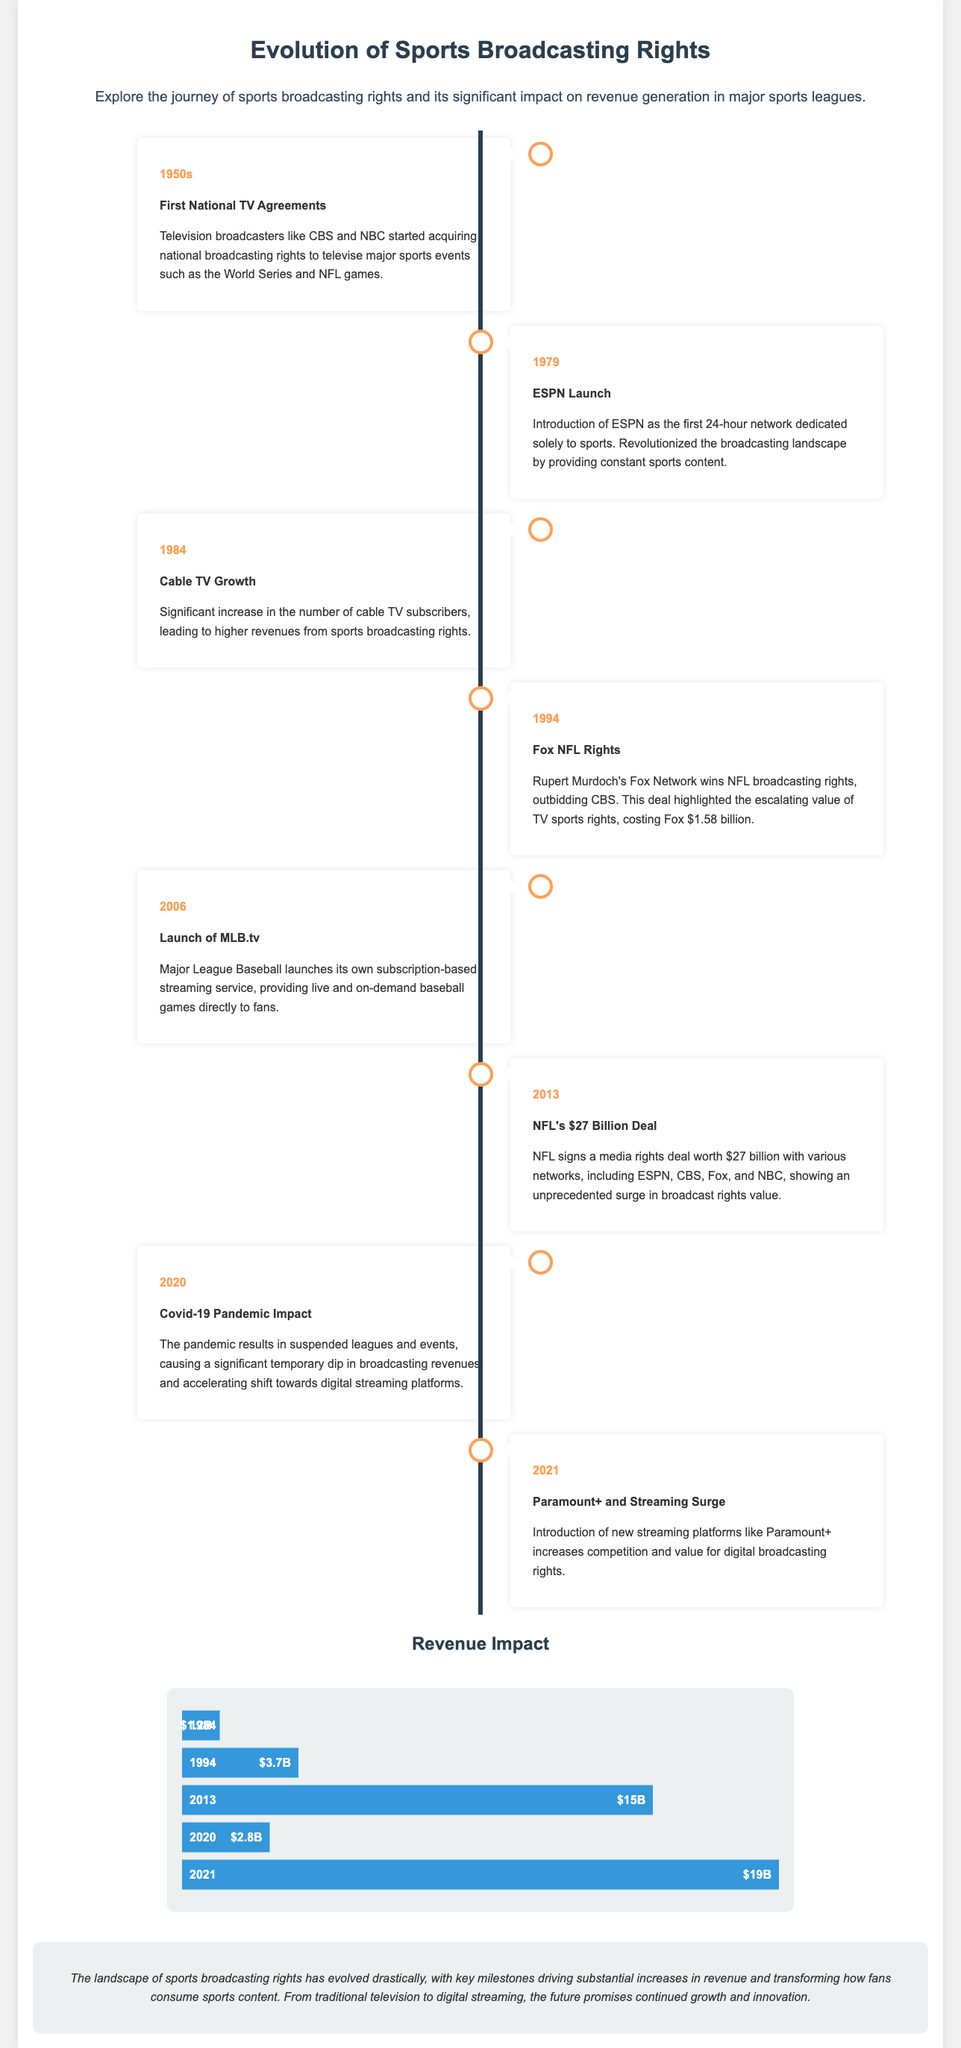What year did ESPN launch? ESPN launched in 1979, marking a significant change in sports broadcasting.
Answer: 1979 What broadcasting rights deal was signed by the NFL in 2013? The NFL signed a media rights deal worth $27 billion with various networks in 2013.
Answer: $27 billion Which network won the NFL broadcasting rights in 1994? Rupert Murdoch's Fox Network won the NFL broadcasting rights in 1994, highlighting the escalating rights' value.
Answer: Fox Network What was the revenue from sports broadcasting rights in 2013? The revenue from sports broadcasting rights in 2013 reached $15 billion, demonstrating a rapid increase.
Answer: $15 billion What impact did the Covid-19 pandemic have on broadcasting revenues in 2020? The pandemic caused a significant temporary dip in broadcasting revenues in 2020 due to suspended leagues and events.
Answer: Dip Which streaming service was launched by Major League Baseball in 2006? Major League Baseball launched its subscription-based streaming service, MLB.tv, in 2006.
Answer: MLB.tv What does the timeline in the infographic represent? The timeline represents key milestones in the evolution of sports broadcasting rights and their impact on revenue generation.
Answer: Key milestones What percentage revenue was recorded in 2020? The revenue recorded from sports broadcasting rights in 2020 was $2.8 billion, corresponding to a specific percentage.
Answer: $2.8 billion What does the final conclusion suggest about the future of sports broadcasting? The conclusion suggests that the future of sports broadcasting promises continued growth and innovation.
Answer: Continued growth and innovation 